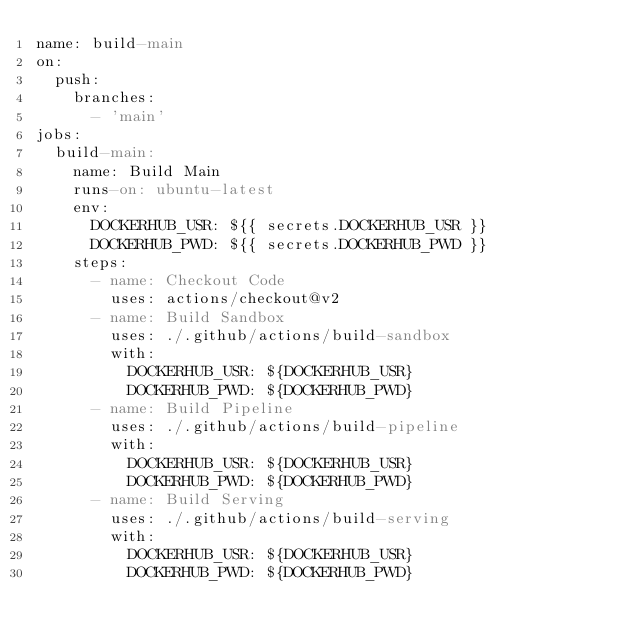<code> <loc_0><loc_0><loc_500><loc_500><_YAML_>name: build-main
on:
  push:
    branches:
      - 'main'
jobs:
  build-main:
    name: Build Main
    runs-on: ubuntu-latest
    env:
      DOCKERHUB_USR: ${{ secrets.DOCKERHUB_USR }}
      DOCKERHUB_PWD: ${{ secrets.DOCKERHUB_PWD }}
    steps:
      - name: Checkout Code
        uses: actions/checkout@v2
      - name: Build Sandbox
        uses: ./.github/actions/build-sandbox
        with:
          DOCKERHUB_USR: ${DOCKERHUB_USR}
          DOCKERHUB_PWD: ${DOCKERHUB_PWD}
      - name: Build Pipeline
        uses: ./.github/actions/build-pipeline
        with:
          DOCKERHUB_USR: ${DOCKERHUB_USR}
          DOCKERHUB_PWD: ${DOCKERHUB_PWD}
      - name: Build Serving
        uses: ./.github/actions/build-serving
        with:
          DOCKERHUB_USR: ${DOCKERHUB_USR}
          DOCKERHUB_PWD: ${DOCKERHUB_PWD}</code> 